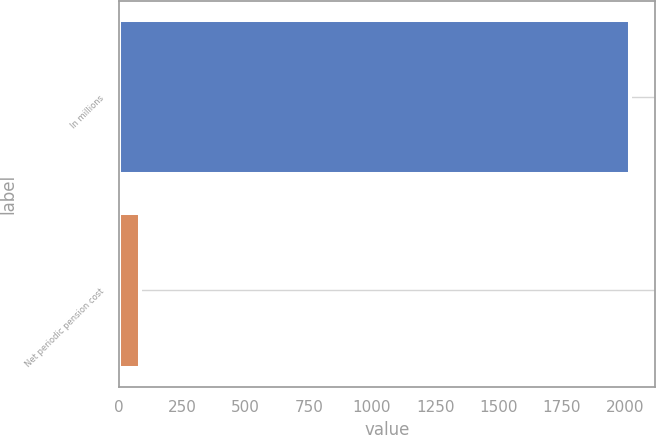<chart> <loc_0><loc_0><loc_500><loc_500><bar_chart><fcel>In millions<fcel>Net periodic pension cost<nl><fcel>2017<fcel>83<nl></chart> 